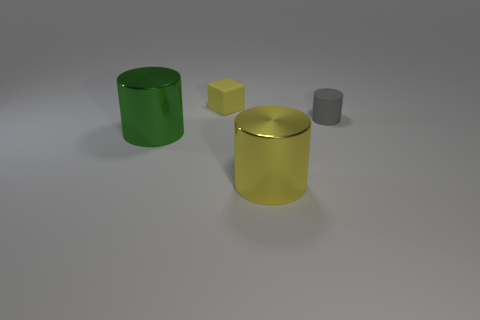Add 4 gray matte cylinders. How many objects exist? 8 Subtract all cylinders. How many objects are left? 1 Add 1 small brown rubber things. How many small brown rubber things exist? 1 Subtract 0 blue cylinders. How many objects are left? 4 Subtract all gray cylinders. Subtract all large cylinders. How many objects are left? 1 Add 2 tiny gray cylinders. How many tiny gray cylinders are left? 3 